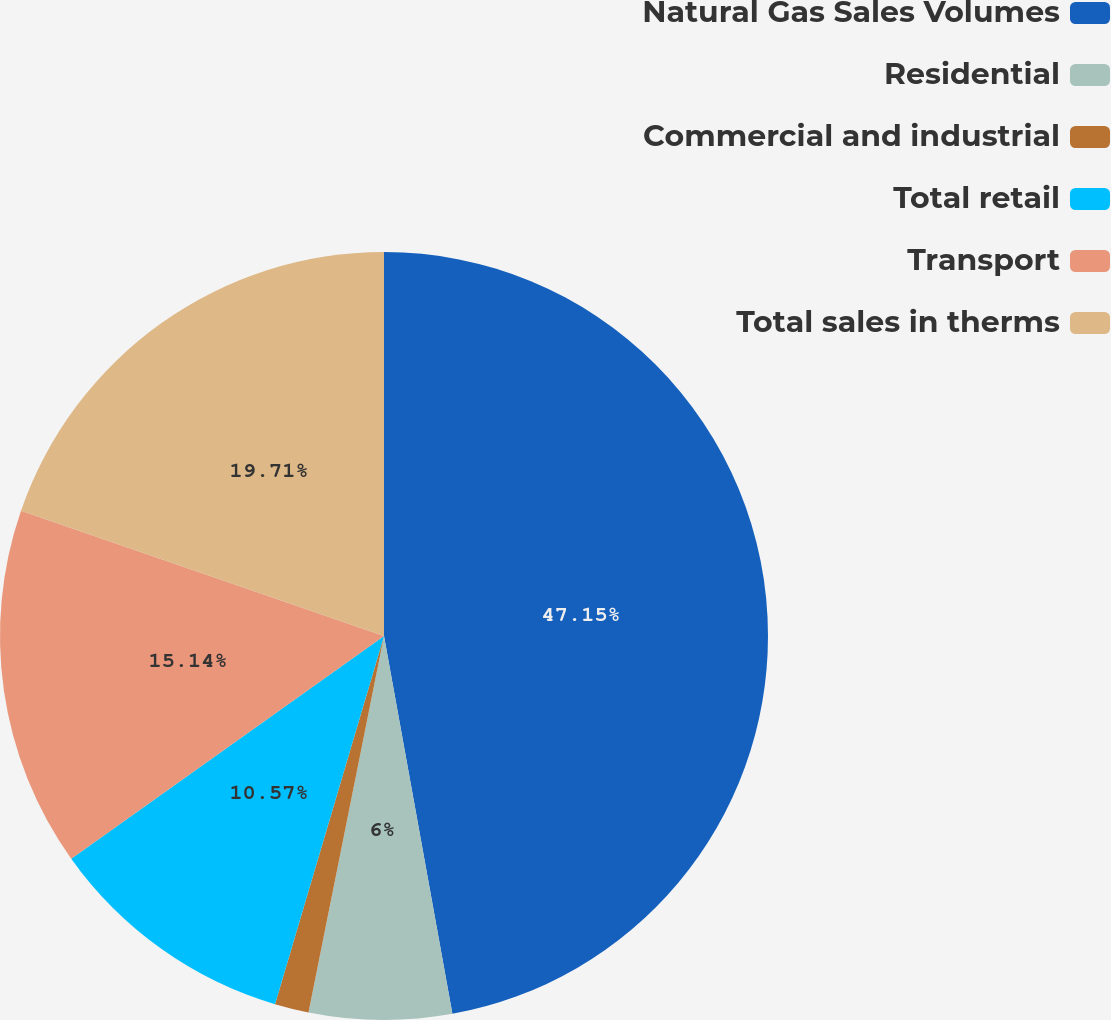Convert chart. <chart><loc_0><loc_0><loc_500><loc_500><pie_chart><fcel>Natural Gas Sales Volumes<fcel>Residential<fcel>Commercial and industrial<fcel>Total retail<fcel>Transport<fcel>Total sales in therms<nl><fcel>47.15%<fcel>6.0%<fcel>1.43%<fcel>10.57%<fcel>15.14%<fcel>19.71%<nl></chart> 